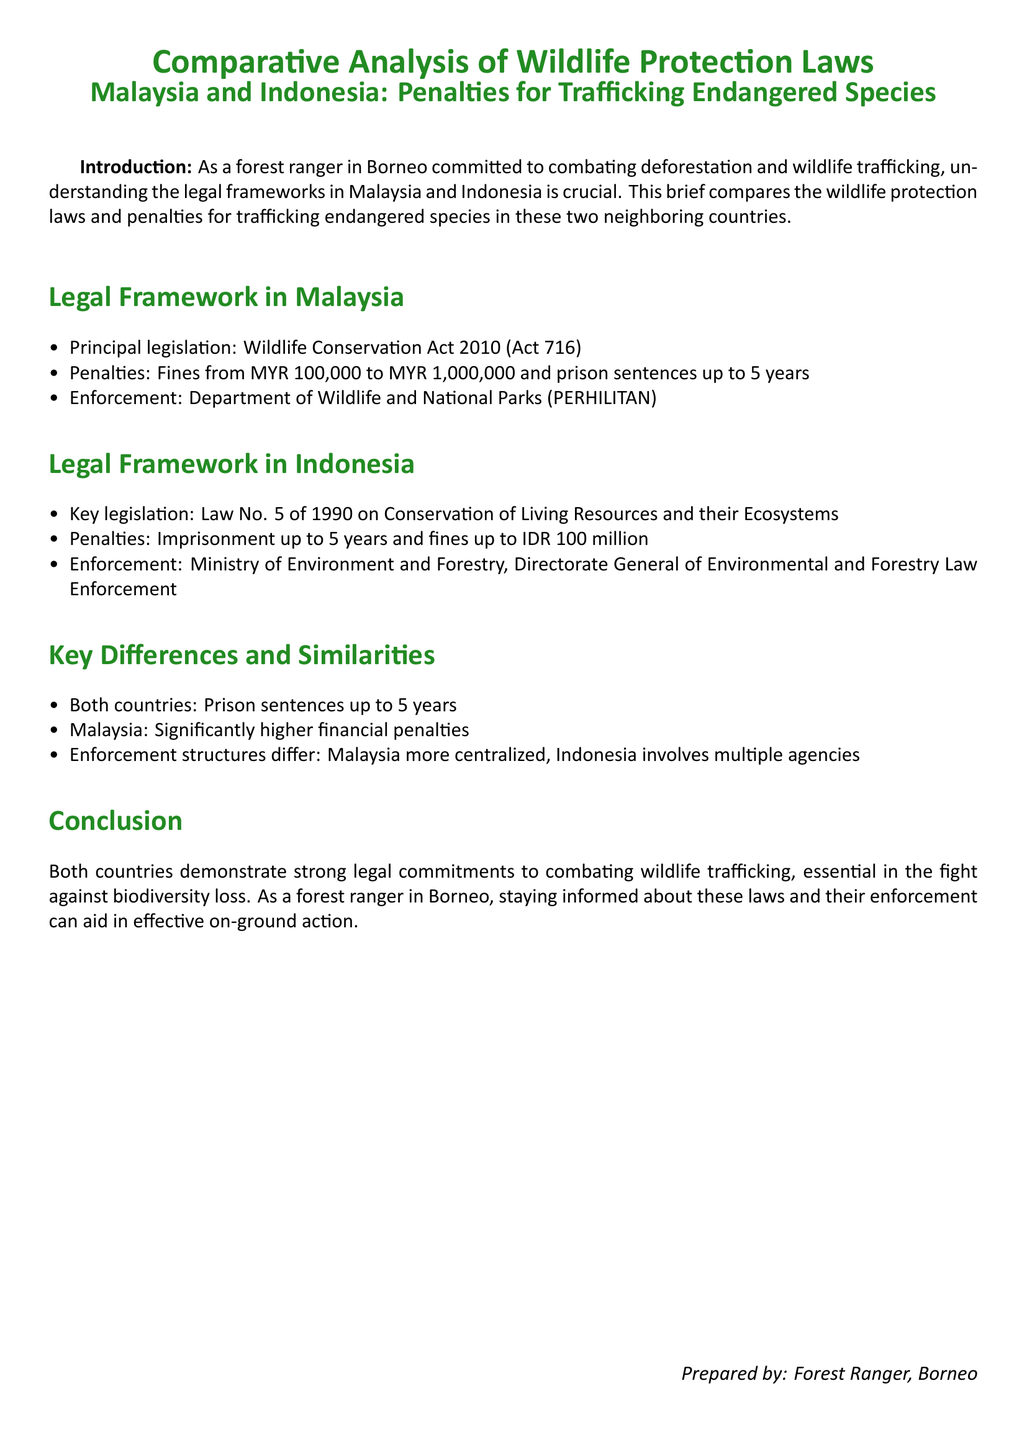what is the principal legislation in Malaysia? The document states that the principal legislation in Malaysia is the Wildlife Conservation Act 2010 (Act 716).
Answer: Wildlife Conservation Act 2010 (Act 716) what is the maximum fine for trafficking endangered species in Malaysia? According to the document, the penalties in Malaysia include fines from MYR 100,000 to MYR 1,000,000. The maximum fine for trafficking is MYR 1,000,000.
Answer: MYR 1,000,000 what is the maximum imprisonment penalty for both countries? The document notes that both Malaysia and Indonesia have a maximum imprisonment penalty of up to 5 years for trafficking endangered species.
Answer: 5 years which agency enforces wildlife laws in Malaysia? The enforcement of wildlife laws in Malaysia is handled by the Department of Wildlife and National Parks (PERHILITAN).
Answer: Department of Wildlife and National Parks (PERHILITAN) what is the key legislation in Indonesia for wildlife protection? The key legislation in Indonesia regarding wildlife protection is Law No. 5 of 1990 on Conservation of Living Resources and their Ecosystems.
Answer: Law No. 5 of 1990 how do the enforcement structures differ between the two countries? The document highlights that Malaysia has a more centralized enforcement structure, whereas Indonesia involves multiple agencies for enforcement.
Answer: Centralized vs. multiple agencies what are the penalties for trafficking endangered species in Indonesia? The penalties outlined in the document for trafficking endangered species in Indonesia include imprisonment up to 5 years and fines up to IDR 100 million.
Answer: Imprisonment up to 5 years and fines up to IDR 100 million which agency enforces wildlife laws in Indonesia? The enforcement of wildlife laws in Indonesia is carried out by the Ministry of Environment and Forestry, Directorate General of Environmental and Forestry Law Enforcement.
Answer: Ministry of Environment and Forestry what is the focus of the document? The focus of the document is a comparative analysis of wildlife protection laws in Malaysia and Indonesia, specifically regarding penalties for trafficking endangered species.
Answer: Comparative analysis of wildlife protection laws 